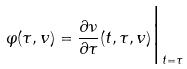<formula> <loc_0><loc_0><loc_500><loc_500>\varphi ( \tau , v ) = \frac { \partial \nu } { \partial \tau } ( t , \tau , v ) \Big | _ { t = \tau }</formula> 